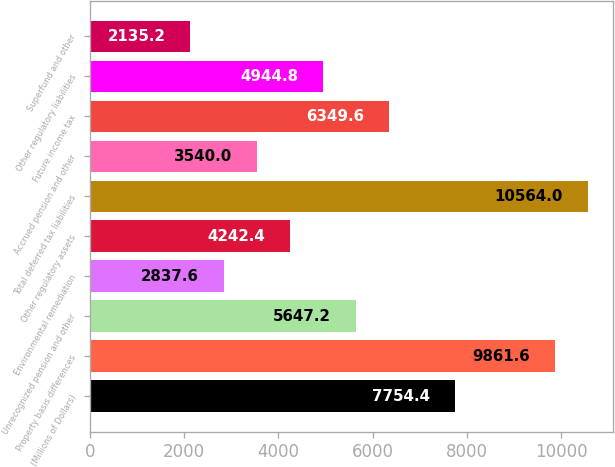<chart> <loc_0><loc_0><loc_500><loc_500><bar_chart><fcel>(Millions of Dollars)<fcel>Property basis differences<fcel>Unrecognized pension and other<fcel>Environmental remediation<fcel>Other regulatory assets<fcel>Total deferred tax liabilities<fcel>Accrued pension and other<fcel>Future income tax<fcel>Other regulatory liabilities<fcel>Superfund and other<nl><fcel>7754.4<fcel>9861.6<fcel>5647.2<fcel>2837.6<fcel>4242.4<fcel>10564<fcel>3540<fcel>6349.6<fcel>4944.8<fcel>2135.2<nl></chart> 